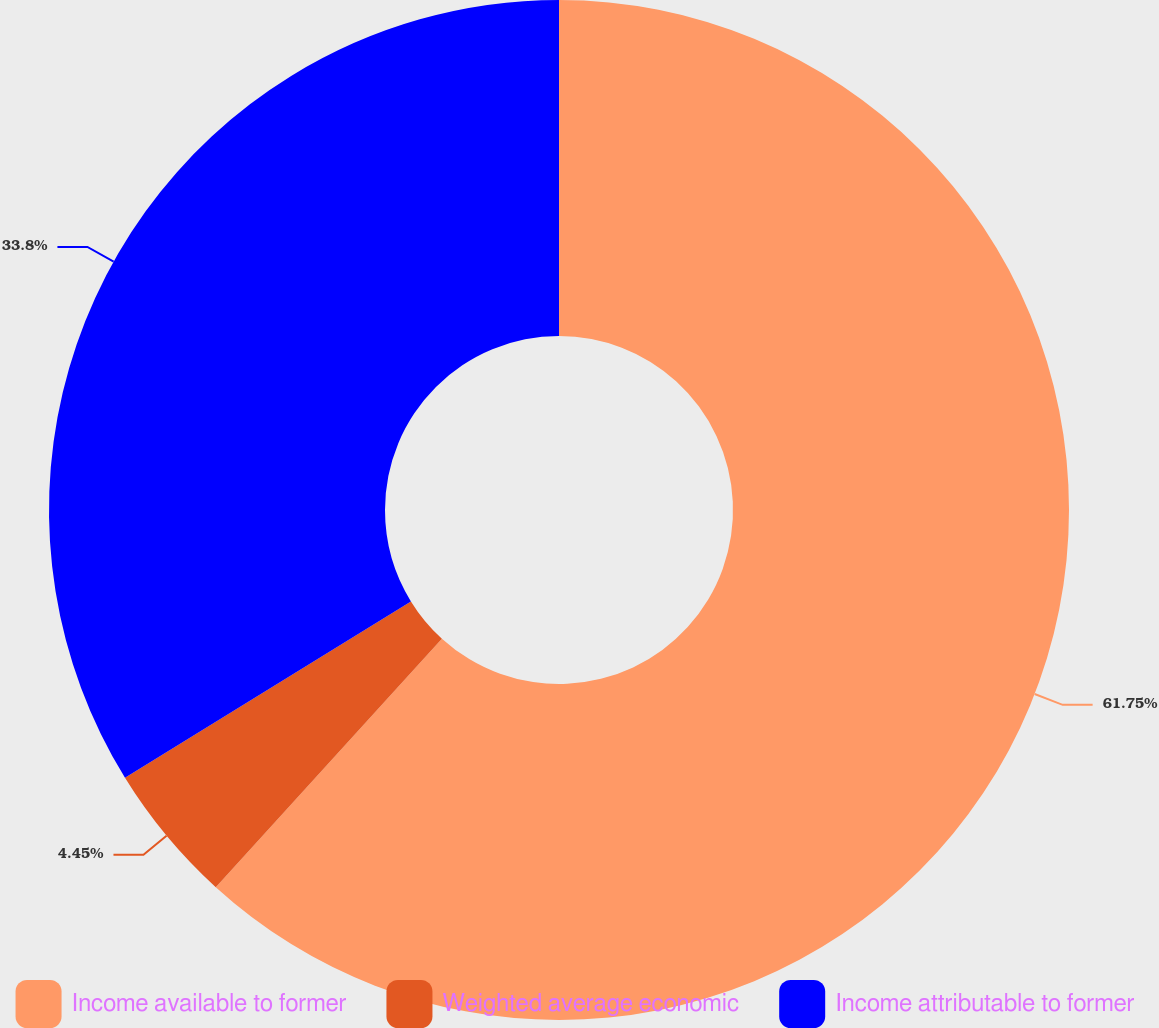Convert chart to OTSL. <chart><loc_0><loc_0><loc_500><loc_500><pie_chart><fcel>Income available to former<fcel>Weighted average economic<fcel>Income attributable to former<nl><fcel>61.75%<fcel>4.45%<fcel>33.8%<nl></chart> 